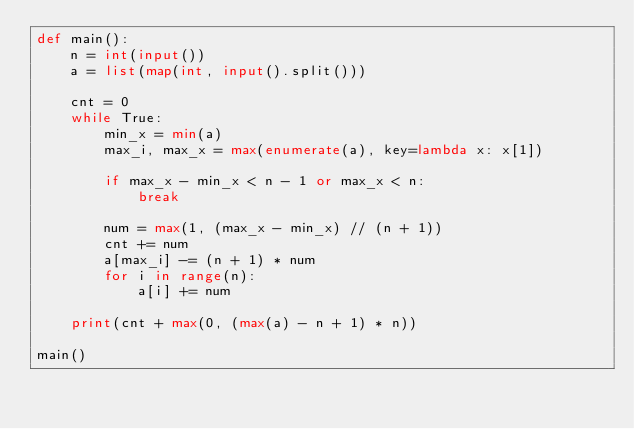Convert code to text. <code><loc_0><loc_0><loc_500><loc_500><_Python_>def main():
    n = int(input())
    a = list(map(int, input().split()))

    cnt = 0
    while True:
        min_x = min(a)
        max_i, max_x = max(enumerate(a), key=lambda x: x[1])

        if max_x - min_x < n - 1 or max_x < n:
            break

        num = max(1, (max_x - min_x) // (n + 1))
        cnt += num
        a[max_i] -= (n + 1) * num
        for i in range(n):
            a[i] += num

    print(cnt + max(0, (max(a) - n + 1) * n))

main()</code> 